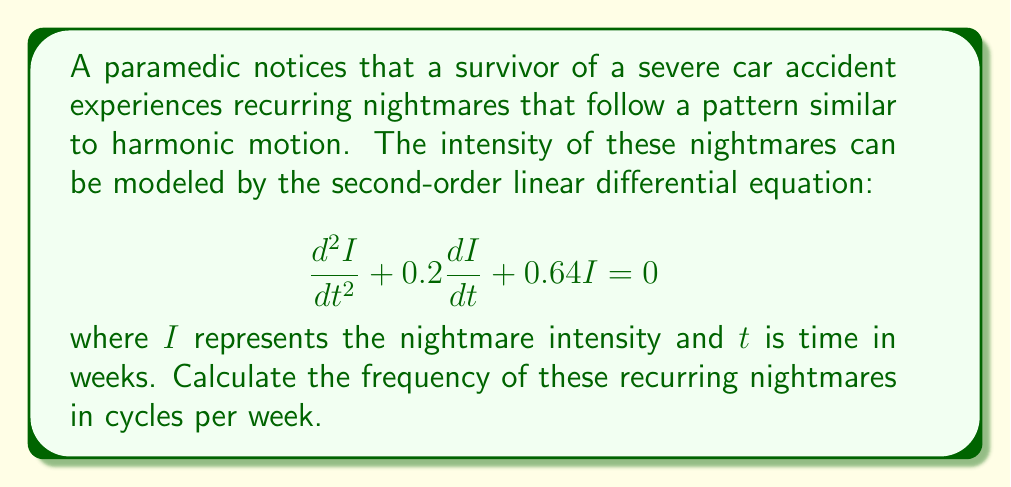Help me with this question. To solve this problem, we need to follow these steps:

1) The given equation is in the form of a damped harmonic oscillator:
   $$\frac{d^2I}{dt^2} + 2\beta\frac{dI}{dt} + \omega_0^2I = 0$$
   where $2\beta = 0.2$ and $\omega_0^2 = 0.64$

2) From this, we can identify:
   $\beta = 0.1$ and $\omega_0 = 0.8$

3) The frequency of damped oscillations is given by:
   $$\omega = \sqrt{\omega_0^2 - \beta^2}$$

4) Substituting the values:
   $$\omega = \sqrt{0.8^2 - 0.1^2} = \sqrt{0.64 - 0.01} = \sqrt{0.63} = 0.7937$$

5) This $\omega$ is in radians per week. To convert to cycles per week, we divide by $2\pi$:
   $$f = \frac{\omega}{2\pi} = \frac{0.7937}{2\pi} \approx 0.1263$$

Therefore, the frequency of the recurring nightmares is approximately 0.1263 cycles per week.
Answer: 0.1263 cycles per week 